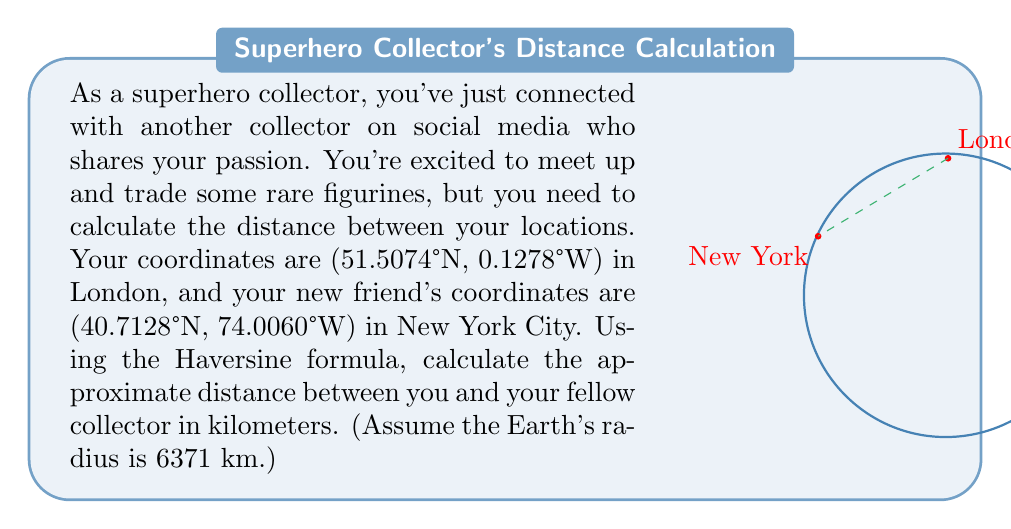Can you solve this math problem? To calculate the distance between two points on Earth using latitude and longitude, we'll use the Haversine formula. Here's the step-by-step process:

1) Convert the latitudes and longitudes from degrees to radians:
   $$\text{lat}_1 = 51.5074° \cdot \frac{\pi}{180} = 0.8990 \text{ rad}$$
   $$\text{lon}_1 = -0.1278° \cdot \frac{\pi}{180} = -0.0022 \text{ rad}$$
   $$\text{lat}_2 = 40.7128° \cdot \frac{\pi}{180} = 0.7104 \text{ rad}$$
   $$\text{lon}_2 = -74.0060° \cdot \frac{\pi}{180} = -1.2917 \text{ rad}$$

2) Calculate the differences in latitude and longitude:
   $$\Delta\text{lat} = \text{lat}_2 - \text{lat}_1 = -0.1886 \text{ rad}$$
   $$\Delta\text{lon} = \text{lon}_2 - \text{lon}_1 = -1.2895 \text{ rad}$$

3) Apply the Haversine formula:
   $$a = \sin^2(\frac{\Delta\text{lat}}{2}) + \cos(\text{lat}_1) \cdot \cos(\text{lat}_2) \cdot \sin^2(\frac{\Delta\text{lon}}{2})$$

   $$a = \sin^2(-0.0943) + \cos(0.8990) \cdot \cos(0.7104) \cdot \sin^2(-0.6447)$$
   $$a = 0.2572$$

4) Calculate the central angle:
   $$c = 2 \cdot \arctan2(\sqrt{a}, \sqrt{1-a})$$
   $$c = 2 \cdot \arctan2(\sqrt{0.2572}, \sqrt{1-0.2572}) = 1.0363 \text{ rad}$$

5) Finally, calculate the distance:
   $$d = R \cdot c$$
   Where $R$ is the Earth's radius (6371 km)
   $$d = 6371 \cdot 1.0363 = 6604.18 \text{ km}$$

Therefore, the approximate distance between London and New York City is 6604.18 km.
Answer: 6604.18 km 